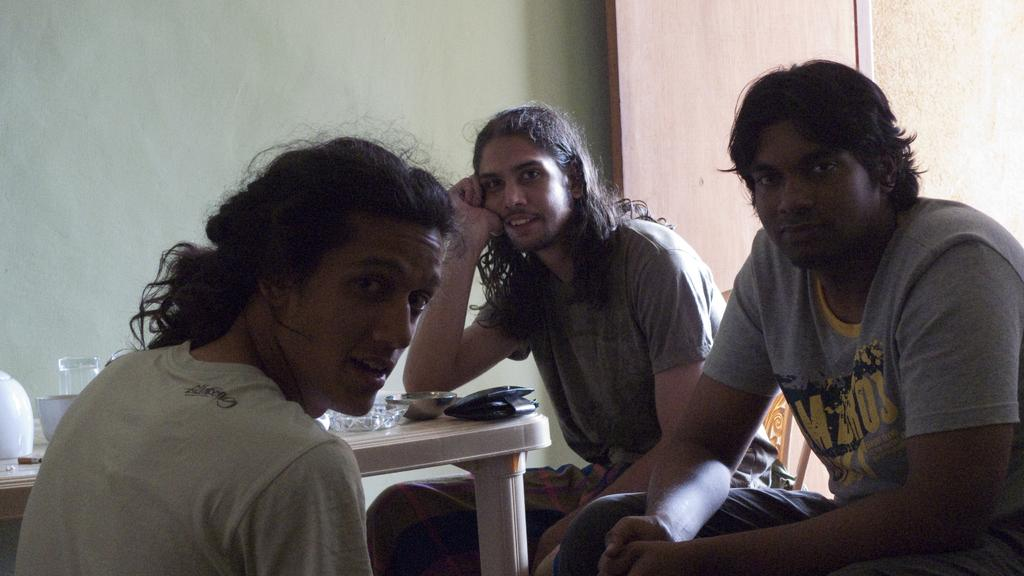How many people are sitting on the chair in the image? There are three persons sitting on a chair in the image. What is in front of the persons? There is a table in front of the persons. What items can be seen on the table? There is a wallet, a bowl, a glass, and a cigar on the table. What type of necklace is the person wearing in the image? There is no necklace visible in the image; the persons are not wearing any jewelry. 